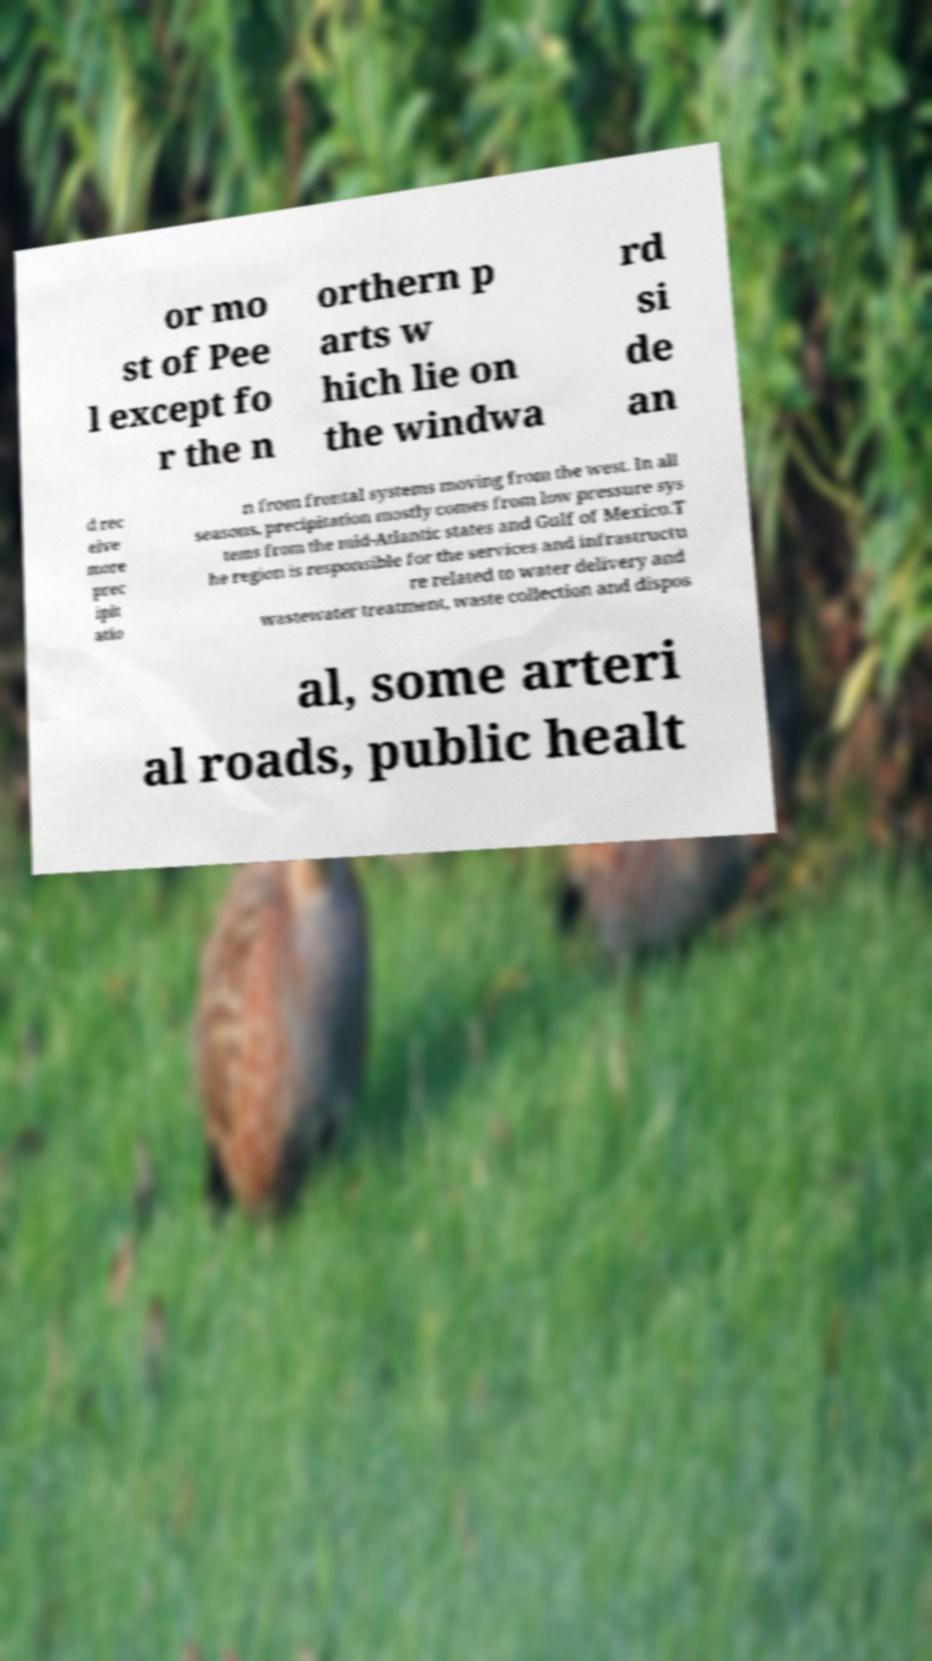Please read and relay the text visible in this image. What does it say? or mo st of Pee l except fo r the n orthern p arts w hich lie on the windwa rd si de an d rec eive more prec ipit atio n from frontal systems moving from the west. In all seasons, precipitation mostly comes from low pressure sys tems from the mid-Atlantic states and Gulf of Mexico.T he region is responsible for the services and infrastructu re related to water delivery and wastewater treatment, waste collection and dispos al, some arteri al roads, public healt 